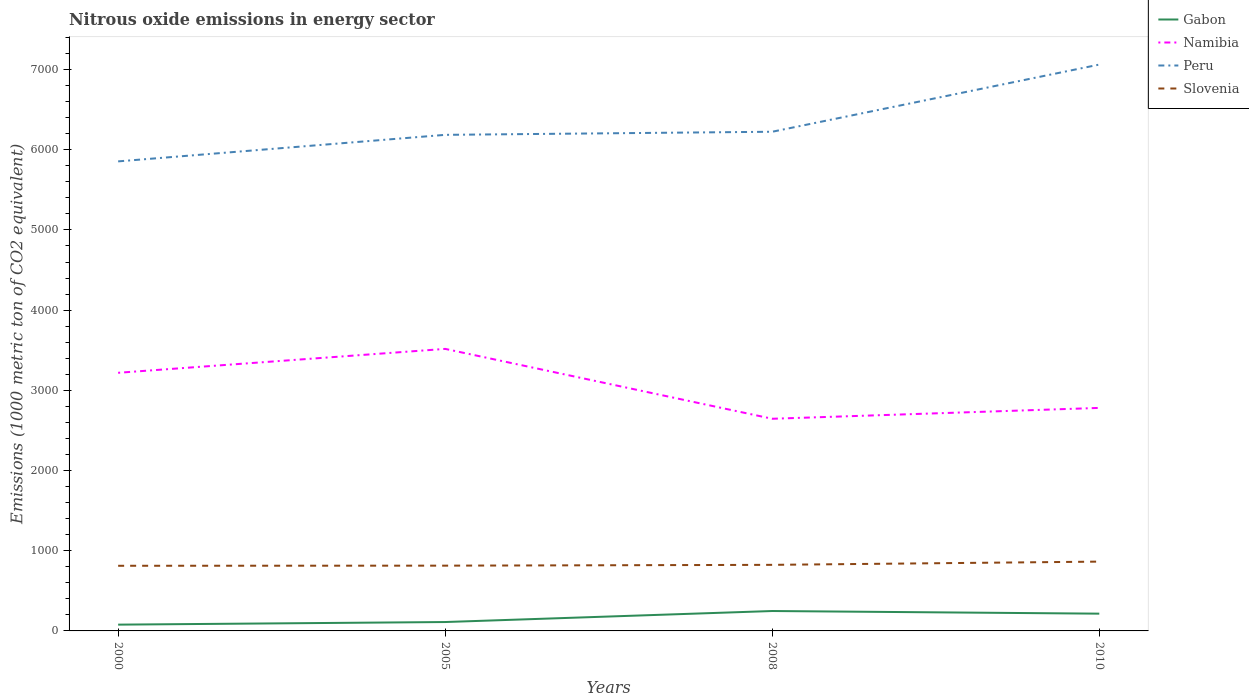How many different coloured lines are there?
Offer a very short reply. 4. Across all years, what is the maximum amount of nitrous oxide emitted in Namibia?
Your answer should be very brief. 2645.5. In which year was the amount of nitrous oxide emitted in Peru maximum?
Offer a very short reply. 2000. What is the total amount of nitrous oxide emitted in Gabon in the graph?
Make the answer very short. -32.5. What is the difference between the highest and the second highest amount of nitrous oxide emitted in Gabon?
Offer a terse response. 169.9. How many lines are there?
Ensure brevity in your answer.  4. Does the graph contain any zero values?
Ensure brevity in your answer.  No. Does the graph contain grids?
Keep it short and to the point. No. Where does the legend appear in the graph?
Your response must be concise. Top right. How many legend labels are there?
Your answer should be compact. 4. How are the legend labels stacked?
Offer a very short reply. Vertical. What is the title of the graph?
Give a very brief answer. Nitrous oxide emissions in energy sector. What is the label or title of the Y-axis?
Your answer should be compact. Emissions (1000 metric ton of CO2 equivalent). What is the Emissions (1000 metric ton of CO2 equivalent) in Gabon in 2000?
Make the answer very short. 78.3. What is the Emissions (1000 metric ton of CO2 equivalent) in Namibia in 2000?
Offer a very short reply. 3218.7. What is the Emissions (1000 metric ton of CO2 equivalent) of Peru in 2000?
Your answer should be very brief. 5854.9. What is the Emissions (1000 metric ton of CO2 equivalent) of Slovenia in 2000?
Offer a terse response. 812.3. What is the Emissions (1000 metric ton of CO2 equivalent) of Gabon in 2005?
Your response must be concise. 110.8. What is the Emissions (1000 metric ton of CO2 equivalent) in Namibia in 2005?
Provide a short and direct response. 3516.8. What is the Emissions (1000 metric ton of CO2 equivalent) of Peru in 2005?
Provide a short and direct response. 6185.8. What is the Emissions (1000 metric ton of CO2 equivalent) in Slovenia in 2005?
Provide a short and direct response. 813.9. What is the Emissions (1000 metric ton of CO2 equivalent) of Gabon in 2008?
Your answer should be compact. 248.2. What is the Emissions (1000 metric ton of CO2 equivalent) in Namibia in 2008?
Provide a succinct answer. 2645.5. What is the Emissions (1000 metric ton of CO2 equivalent) in Peru in 2008?
Your answer should be very brief. 6224.5. What is the Emissions (1000 metric ton of CO2 equivalent) in Slovenia in 2008?
Provide a short and direct response. 823.9. What is the Emissions (1000 metric ton of CO2 equivalent) of Gabon in 2010?
Give a very brief answer. 215.3. What is the Emissions (1000 metric ton of CO2 equivalent) of Namibia in 2010?
Provide a succinct answer. 2780.9. What is the Emissions (1000 metric ton of CO2 equivalent) of Peru in 2010?
Keep it short and to the point. 7062. What is the Emissions (1000 metric ton of CO2 equivalent) in Slovenia in 2010?
Keep it short and to the point. 864.2. Across all years, what is the maximum Emissions (1000 metric ton of CO2 equivalent) in Gabon?
Provide a short and direct response. 248.2. Across all years, what is the maximum Emissions (1000 metric ton of CO2 equivalent) in Namibia?
Your answer should be very brief. 3516.8. Across all years, what is the maximum Emissions (1000 metric ton of CO2 equivalent) of Peru?
Provide a succinct answer. 7062. Across all years, what is the maximum Emissions (1000 metric ton of CO2 equivalent) of Slovenia?
Make the answer very short. 864.2. Across all years, what is the minimum Emissions (1000 metric ton of CO2 equivalent) in Gabon?
Give a very brief answer. 78.3. Across all years, what is the minimum Emissions (1000 metric ton of CO2 equivalent) in Namibia?
Your answer should be compact. 2645.5. Across all years, what is the minimum Emissions (1000 metric ton of CO2 equivalent) in Peru?
Provide a short and direct response. 5854.9. Across all years, what is the minimum Emissions (1000 metric ton of CO2 equivalent) of Slovenia?
Provide a succinct answer. 812.3. What is the total Emissions (1000 metric ton of CO2 equivalent) of Gabon in the graph?
Your answer should be very brief. 652.6. What is the total Emissions (1000 metric ton of CO2 equivalent) in Namibia in the graph?
Offer a very short reply. 1.22e+04. What is the total Emissions (1000 metric ton of CO2 equivalent) in Peru in the graph?
Your answer should be very brief. 2.53e+04. What is the total Emissions (1000 metric ton of CO2 equivalent) in Slovenia in the graph?
Your answer should be very brief. 3314.3. What is the difference between the Emissions (1000 metric ton of CO2 equivalent) in Gabon in 2000 and that in 2005?
Keep it short and to the point. -32.5. What is the difference between the Emissions (1000 metric ton of CO2 equivalent) of Namibia in 2000 and that in 2005?
Offer a terse response. -298.1. What is the difference between the Emissions (1000 metric ton of CO2 equivalent) of Peru in 2000 and that in 2005?
Offer a very short reply. -330.9. What is the difference between the Emissions (1000 metric ton of CO2 equivalent) of Slovenia in 2000 and that in 2005?
Keep it short and to the point. -1.6. What is the difference between the Emissions (1000 metric ton of CO2 equivalent) of Gabon in 2000 and that in 2008?
Offer a terse response. -169.9. What is the difference between the Emissions (1000 metric ton of CO2 equivalent) of Namibia in 2000 and that in 2008?
Your response must be concise. 573.2. What is the difference between the Emissions (1000 metric ton of CO2 equivalent) in Peru in 2000 and that in 2008?
Provide a short and direct response. -369.6. What is the difference between the Emissions (1000 metric ton of CO2 equivalent) in Slovenia in 2000 and that in 2008?
Your answer should be very brief. -11.6. What is the difference between the Emissions (1000 metric ton of CO2 equivalent) of Gabon in 2000 and that in 2010?
Ensure brevity in your answer.  -137. What is the difference between the Emissions (1000 metric ton of CO2 equivalent) in Namibia in 2000 and that in 2010?
Give a very brief answer. 437.8. What is the difference between the Emissions (1000 metric ton of CO2 equivalent) of Peru in 2000 and that in 2010?
Your response must be concise. -1207.1. What is the difference between the Emissions (1000 metric ton of CO2 equivalent) in Slovenia in 2000 and that in 2010?
Ensure brevity in your answer.  -51.9. What is the difference between the Emissions (1000 metric ton of CO2 equivalent) of Gabon in 2005 and that in 2008?
Offer a very short reply. -137.4. What is the difference between the Emissions (1000 metric ton of CO2 equivalent) in Namibia in 2005 and that in 2008?
Your response must be concise. 871.3. What is the difference between the Emissions (1000 metric ton of CO2 equivalent) in Peru in 2005 and that in 2008?
Offer a terse response. -38.7. What is the difference between the Emissions (1000 metric ton of CO2 equivalent) of Gabon in 2005 and that in 2010?
Provide a short and direct response. -104.5. What is the difference between the Emissions (1000 metric ton of CO2 equivalent) of Namibia in 2005 and that in 2010?
Make the answer very short. 735.9. What is the difference between the Emissions (1000 metric ton of CO2 equivalent) of Peru in 2005 and that in 2010?
Provide a succinct answer. -876.2. What is the difference between the Emissions (1000 metric ton of CO2 equivalent) of Slovenia in 2005 and that in 2010?
Give a very brief answer. -50.3. What is the difference between the Emissions (1000 metric ton of CO2 equivalent) in Gabon in 2008 and that in 2010?
Ensure brevity in your answer.  32.9. What is the difference between the Emissions (1000 metric ton of CO2 equivalent) in Namibia in 2008 and that in 2010?
Ensure brevity in your answer.  -135.4. What is the difference between the Emissions (1000 metric ton of CO2 equivalent) of Peru in 2008 and that in 2010?
Offer a very short reply. -837.5. What is the difference between the Emissions (1000 metric ton of CO2 equivalent) in Slovenia in 2008 and that in 2010?
Provide a short and direct response. -40.3. What is the difference between the Emissions (1000 metric ton of CO2 equivalent) of Gabon in 2000 and the Emissions (1000 metric ton of CO2 equivalent) of Namibia in 2005?
Give a very brief answer. -3438.5. What is the difference between the Emissions (1000 metric ton of CO2 equivalent) of Gabon in 2000 and the Emissions (1000 metric ton of CO2 equivalent) of Peru in 2005?
Your answer should be compact. -6107.5. What is the difference between the Emissions (1000 metric ton of CO2 equivalent) of Gabon in 2000 and the Emissions (1000 metric ton of CO2 equivalent) of Slovenia in 2005?
Give a very brief answer. -735.6. What is the difference between the Emissions (1000 metric ton of CO2 equivalent) in Namibia in 2000 and the Emissions (1000 metric ton of CO2 equivalent) in Peru in 2005?
Offer a very short reply. -2967.1. What is the difference between the Emissions (1000 metric ton of CO2 equivalent) of Namibia in 2000 and the Emissions (1000 metric ton of CO2 equivalent) of Slovenia in 2005?
Provide a short and direct response. 2404.8. What is the difference between the Emissions (1000 metric ton of CO2 equivalent) in Peru in 2000 and the Emissions (1000 metric ton of CO2 equivalent) in Slovenia in 2005?
Your response must be concise. 5041. What is the difference between the Emissions (1000 metric ton of CO2 equivalent) of Gabon in 2000 and the Emissions (1000 metric ton of CO2 equivalent) of Namibia in 2008?
Offer a terse response. -2567.2. What is the difference between the Emissions (1000 metric ton of CO2 equivalent) of Gabon in 2000 and the Emissions (1000 metric ton of CO2 equivalent) of Peru in 2008?
Offer a very short reply. -6146.2. What is the difference between the Emissions (1000 metric ton of CO2 equivalent) in Gabon in 2000 and the Emissions (1000 metric ton of CO2 equivalent) in Slovenia in 2008?
Your response must be concise. -745.6. What is the difference between the Emissions (1000 metric ton of CO2 equivalent) in Namibia in 2000 and the Emissions (1000 metric ton of CO2 equivalent) in Peru in 2008?
Ensure brevity in your answer.  -3005.8. What is the difference between the Emissions (1000 metric ton of CO2 equivalent) of Namibia in 2000 and the Emissions (1000 metric ton of CO2 equivalent) of Slovenia in 2008?
Offer a terse response. 2394.8. What is the difference between the Emissions (1000 metric ton of CO2 equivalent) of Peru in 2000 and the Emissions (1000 metric ton of CO2 equivalent) of Slovenia in 2008?
Your response must be concise. 5031. What is the difference between the Emissions (1000 metric ton of CO2 equivalent) in Gabon in 2000 and the Emissions (1000 metric ton of CO2 equivalent) in Namibia in 2010?
Offer a very short reply. -2702.6. What is the difference between the Emissions (1000 metric ton of CO2 equivalent) of Gabon in 2000 and the Emissions (1000 metric ton of CO2 equivalent) of Peru in 2010?
Offer a very short reply. -6983.7. What is the difference between the Emissions (1000 metric ton of CO2 equivalent) in Gabon in 2000 and the Emissions (1000 metric ton of CO2 equivalent) in Slovenia in 2010?
Your response must be concise. -785.9. What is the difference between the Emissions (1000 metric ton of CO2 equivalent) of Namibia in 2000 and the Emissions (1000 metric ton of CO2 equivalent) of Peru in 2010?
Your answer should be very brief. -3843.3. What is the difference between the Emissions (1000 metric ton of CO2 equivalent) of Namibia in 2000 and the Emissions (1000 metric ton of CO2 equivalent) of Slovenia in 2010?
Ensure brevity in your answer.  2354.5. What is the difference between the Emissions (1000 metric ton of CO2 equivalent) of Peru in 2000 and the Emissions (1000 metric ton of CO2 equivalent) of Slovenia in 2010?
Make the answer very short. 4990.7. What is the difference between the Emissions (1000 metric ton of CO2 equivalent) in Gabon in 2005 and the Emissions (1000 metric ton of CO2 equivalent) in Namibia in 2008?
Ensure brevity in your answer.  -2534.7. What is the difference between the Emissions (1000 metric ton of CO2 equivalent) of Gabon in 2005 and the Emissions (1000 metric ton of CO2 equivalent) of Peru in 2008?
Keep it short and to the point. -6113.7. What is the difference between the Emissions (1000 metric ton of CO2 equivalent) of Gabon in 2005 and the Emissions (1000 metric ton of CO2 equivalent) of Slovenia in 2008?
Your response must be concise. -713.1. What is the difference between the Emissions (1000 metric ton of CO2 equivalent) in Namibia in 2005 and the Emissions (1000 metric ton of CO2 equivalent) in Peru in 2008?
Provide a succinct answer. -2707.7. What is the difference between the Emissions (1000 metric ton of CO2 equivalent) of Namibia in 2005 and the Emissions (1000 metric ton of CO2 equivalent) of Slovenia in 2008?
Ensure brevity in your answer.  2692.9. What is the difference between the Emissions (1000 metric ton of CO2 equivalent) of Peru in 2005 and the Emissions (1000 metric ton of CO2 equivalent) of Slovenia in 2008?
Keep it short and to the point. 5361.9. What is the difference between the Emissions (1000 metric ton of CO2 equivalent) of Gabon in 2005 and the Emissions (1000 metric ton of CO2 equivalent) of Namibia in 2010?
Your answer should be compact. -2670.1. What is the difference between the Emissions (1000 metric ton of CO2 equivalent) of Gabon in 2005 and the Emissions (1000 metric ton of CO2 equivalent) of Peru in 2010?
Offer a terse response. -6951.2. What is the difference between the Emissions (1000 metric ton of CO2 equivalent) in Gabon in 2005 and the Emissions (1000 metric ton of CO2 equivalent) in Slovenia in 2010?
Keep it short and to the point. -753.4. What is the difference between the Emissions (1000 metric ton of CO2 equivalent) of Namibia in 2005 and the Emissions (1000 metric ton of CO2 equivalent) of Peru in 2010?
Provide a succinct answer. -3545.2. What is the difference between the Emissions (1000 metric ton of CO2 equivalent) of Namibia in 2005 and the Emissions (1000 metric ton of CO2 equivalent) of Slovenia in 2010?
Your answer should be compact. 2652.6. What is the difference between the Emissions (1000 metric ton of CO2 equivalent) in Peru in 2005 and the Emissions (1000 metric ton of CO2 equivalent) in Slovenia in 2010?
Your response must be concise. 5321.6. What is the difference between the Emissions (1000 metric ton of CO2 equivalent) of Gabon in 2008 and the Emissions (1000 metric ton of CO2 equivalent) of Namibia in 2010?
Offer a very short reply. -2532.7. What is the difference between the Emissions (1000 metric ton of CO2 equivalent) of Gabon in 2008 and the Emissions (1000 metric ton of CO2 equivalent) of Peru in 2010?
Your answer should be very brief. -6813.8. What is the difference between the Emissions (1000 metric ton of CO2 equivalent) of Gabon in 2008 and the Emissions (1000 metric ton of CO2 equivalent) of Slovenia in 2010?
Your response must be concise. -616. What is the difference between the Emissions (1000 metric ton of CO2 equivalent) of Namibia in 2008 and the Emissions (1000 metric ton of CO2 equivalent) of Peru in 2010?
Provide a succinct answer. -4416.5. What is the difference between the Emissions (1000 metric ton of CO2 equivalent) of Namibia in 2008 and the Emissions (1000 metric ton of CO2 equivalent) of Slovenia in 2010?
Provide a short and direct response. 1781.3. What is the difference between the Emissions (1000 metric ton of CO2 equivalent) of Peru in 2008 and the Emissions (1000 metric ton of CO2 equivalent) of Slovenia in 2010?
Provide a short and direct response. 5360.3. What is the average Emissions (1000 metric ton of CO2 equivalent) in Gabon per year?
Offer a very short reply. 163.15. What is the average Emissions (1000 metric ton of CO2 equivalent) in Namibia per year?
Give a very brief answer. 3040.47. What is the average Emissions (1000 metric ton of CO2 equivalent) in Peru per year?
Offer a terse response. 6331.8. What is the average Emissions (1000 metric ton of CO2 equivalent) in Slovenia per year?
Your response must be concise. 828.58. In the year 2000, what is the difference between the Emissions (1000 metric ton of CO2 equivalent) of Gabon and Emissions (1000 metric ton of CO2 equivalent) of Namibia?
Provide a succinct answer. -3140.4. In the year 2000, what is the difference between the Emissions (1000 metric ton of CO2 equivalent) in Gabon and Emissions (1000 metric ton of CO2 equivalent) in Peru?
Keep it short and to the point. -5776.6. In the year 2000, what is the difference between the Emissions (1000 metric ton of CO2 equivalent) of Gabon and Emissions (1000 metric ton of CO2 equivalent) of Slovenia?
Give a very brief answer. -734. In the year 2000, what is the difference between the Emissions (1000 metric ton of CO2 equivalent) in Namibia and Emissions (1000 metric ton of CO2 equivalent) in Peru?
Your answer should be compact. -2636.2. In the year 2000, what is the difference between the Emissions (1000 metric ton of CO2 equivalent) in Namibia and Emissions (1000 metric ton of CO2 equivalent) in Slovenia?
Your response must be concise. 2406.4. In the year 2000, what is the difference between the Emissions (1000 metric ton of CO2 equivalent) in Peru and Emissions (1000 metric ton of CO2 equivalent) in Slovenia?
Provide a succinct answer. 5042.6. In the year 2005, what is the difference between the Emissions (1000 metric ton of CO2 equivalent) of Gabon and Emissions (1000 metric ton of CO2 equivalent) of Namibia?
Offer a terse response. -3406. In the year 2005, what is the difference between the Emissions (1000 metric ton of CO2 equivalent) in Gabon and Emissions (1000 metric ton of CO2 equivalent) in Peru?
Keep it short and to the point. -6075. In the year 2005, what is the difference between the Emissions (1000 metric ton of CO2 equivalent) in Gabon and Emissions (1000 metric ton of CO2 equivalent) in Slovenia?
Your response must be concise. -703.1. In the year 2005, what is the difference between the Emissions (1000 metric ton of CO2 equivalent) in Namibia and Emissions (1000 metric ton of CO2 equivalent) in Peru?
Your answer should be compact. -2669. In the year 2005, what is the difference between the Emissions (1000 metric ton of CO2 equivalent) of Namibia and Emissions (1000 metric ton of CO2 equivalent) of Slovenia?
Ensure brevity in your answer.  2702.9. In the year 2005, what is the difference between the Emissions (1000 metric ton of CO2 equivalent) of Peru and Emissions (1000 metric ton of CO2 equivalent) of Slovenia?
Provide a short and direct response. 5371.9. In the year 2008, what is the difference between the Emissions (1000 metric ton of CO2 equivalent) in Gabon and Emissions (1000 metric ton of CO2 equivalent) in Namibia?
Make the answer very short. -2397.3. In the year 2008, what is the difference between the Emissions (1000 metric ton of CO2 equivalent) of Gabon and Emissions (1000 metric ton of CO2 equivalent) of Peru?
Provide a short and direct response. -5976.3. In the year 2008, what is the difference between the Emissions (1000 metric ton of CO2 equivalent) in Gabon and Emissions (1000 metric ton of CO2 equivalent) in Slovenia?
Your answer should be compact. -575.7. In the year 2008, what is the difference between the Emissions (1000 metric ton of CO2 equivalent) in Namibia and Emissions (1000 metric ton of CO2 equivalent) in Peru?
Provide a succinct answer. -3579. In the year 2008, what is the difference between the Emissions (1000 metric ton of CO2 equivalent) in Namibia and Emissions (1000 metric ton of CO2 equivalent) in Slovenia?
Keep it short and to the point. 1821.6. In the year 2008, what is the difference between the Emissions (1000 metric ton of CO2 equivalent) of Peru and Emissions (1000 metric ton of CO2 equivalent) of Slovenia?
Provide a succinct answer. 5400.6. In the year 2010, what is the difference between the Emissions (1000 metric ton of CO2 equivalent) in Gabon and Emissions (1000 metric ton of CO2 equivalent) in Namibia?
Give a very brief answer. -2565.6. In the year 2010, what is the difference between the Emissions (1000 metric ton of CO2 equivalent) in Gabon and Emissions (1000 metric ton of CO2 equivalent) in Peru?
Provide a short and direct response. -6846.7. In the year 2010, what is the difference between the Emissions (1000 metric ton of CO2 equivalent) in Gabon and Emissions (1000 metric ton of CO2 equivalent) in Slovenia?
Ensure brevity in your answer.  -648.9. In the year 2010, what is the difference between the Emissions (1000 metric ton of CO2 equivalent) of Namibia and Emissions (1000 metric ton of CO2 equivalent) of Peru?
Your response must be concise. -4281.1. In the year 2010, what is the difference between the Emissions (1000 metric ton of CO2 equivalent) of Namibia and Emissions (1000 metric ton of CO2 equivalent) of Slovenia?
Provide a succinct answer. 1916.7. In the year 2010, what is the difference between the Emissions (1000 metric ton of CO2 equivalent) of Peru and Emissions (1000 metric ton of CO2 equivalent) of Slovenia?
Offer a terse response. 6197.8. What is the ratio of the Emissions (1000 metric ton of CO2 equivalent) of Gabon in 2000 to that in 2005?
Your response must be concise. 0.71. What is the ratio of the Emissions (1000 metric ton of CO2 equivalent) in Namibia in 2000 to that in 2005?
Keep it short and to the point. 0.92. What is the ratio of the Emissions (1000 metric ton of CO2 equivalent) of Peru in 2000 to that in 2005?
Your response must be concise. 0.95. What is the ratio of the Emissions (1000 metric ton of CO2 equivalent) of Gabon in 2000 to that in 2008?
Make the answer very short. 0.32. What is the ratio of the Emissions (1000 metric ton of CO2 equivalent) of Namibia in 2000 to that in 2008?
Your answer should be very brief. 1.22. What is the ratio of the Emissions (1000 metric ton of CO2 equivalent) of Peru in 2000 to that in 2008?
Your response must be concise. 0.94. What is the ratio of the Emissions (1000 metric ton of CO2 equivalent) in Slovenia in 2000 to that in 2008?
Provide a succinct answer. 0.99. What is the ratio of the Emissions (1000 metric ton of CO2 equivalent) in Gabon in 2000 to that in 2010?
Your answer should be very brief. 0.36. What is the ratio of the Emissions (1000 metric ton of CO2 equivalent) of Namibia in 2000 to that in 2010?
Offer a very short reply. 1.16. What is the ratio of the Emissions (1000 metric ton of CO2 equivalent) of Peru in 2000 to that in 2010?
Offer a very short reply. 0.83. What is the ratio of the Emissions (1000 metric ton of CO2 equivalent) of Slovenia in 2000 to that in 2010?
Your answer should be compact. 0.94. What is the ratio of the Emissions (1000 metric ton of CO2 equivalent) of Gabon in 2005 to that in 2008?
Offer a very short reply. 0.45. What is the ratio of the Emissions (1000 metric ton of CO2 equivalent) in Namibia in 2005 to that in 2008?
Ensure brevity in your answer.  1.33. What is the ratio of the Emissions (1000 metric ton of CO2 equivalent) of Slovenia in 2005 to that in 2008?
Give a very brief answer. 0.99. What is the ratio of the Emissions (1000 metric ton of CO2 equivalent) of Gabon in 2005 to that in 2010?
Give a very brief answer. 0.51. What is the ratio of the Emissions (1000 metric ton of CO2 equivalent) in Namibia in 2005 to that in 2010?
Offer a terse response. 1.26. What is the ratio of the Emissions (1000 metric ton of CO2 equivalent) of Peru in 2005 to that in 2010?
Offer a very short reply. 0.88. What is the ratio of the Emissions (1000 metric ton of CO2 equivalent) in Slovenia in 2005 to that in 2010?
Provide a succinct answer. 0.94. What is the ratio of the Emissions (1000 metric ton of CO2 equivalent) in Gabon in 2008 to that in 2010?
Offer a terse response. 1.15. What is the ratio of the Emissions (1000 metric ton of CO2 equivalent) of Namibia in 2008 to that in 2010?
Make the answer very short. 0.95. What is the ratio of the Emissions (1000 metric ton of CO2 equivalent) in Peru in 2008 to that in 2010?
Your answer should be compact. 0.88. What is the ratio of the Emissions (1000 metric ton of CO2 equivalent) of Slovenia in 2008 to that in 2010?
Your response must be concise. 0.95. What is the difference between the highest and the second highest Emissions (1000 metric ton of CO2 equivalent) in Gabon?
Offer a terse response. 32.9. What is the difference between the highest and the second highest Emissions (1000 metric ton of CO2 equivalent) in Namibia?
Offer a very short reply. 298.1. What is the difference between the highest and the second highest Emissions (1000 metric ton of CO2 equivalent) in Peru?
Your response must be concise. 837.5. What is the difference between the highest and the second highest Emissions (1000 metric ton of CO2 equivalent) of Slovenia?
Provide a succinct answer. 40.3. What is the difference between the highest and the lowest Emissions (1000 metric ton of CO2 equivalent) of Gabon?
Make the answer very short. 169.9. What is the difference between the highest and the lowest Emissions (1000 metric ton of CO2 equivalent) in Namibia?
Your response must be concise. 871.3. What is the difference between the highest and the lowest Emissions (1000 metric ton of CO2 equivalent) of Peru?
Give a very brief answer. 1207.1. What is the difference between the highest and the lowest Emissions (1000 metric ton of CO2 equivalent) in Slovenia?
Provide a succinct answer. 51.9. 